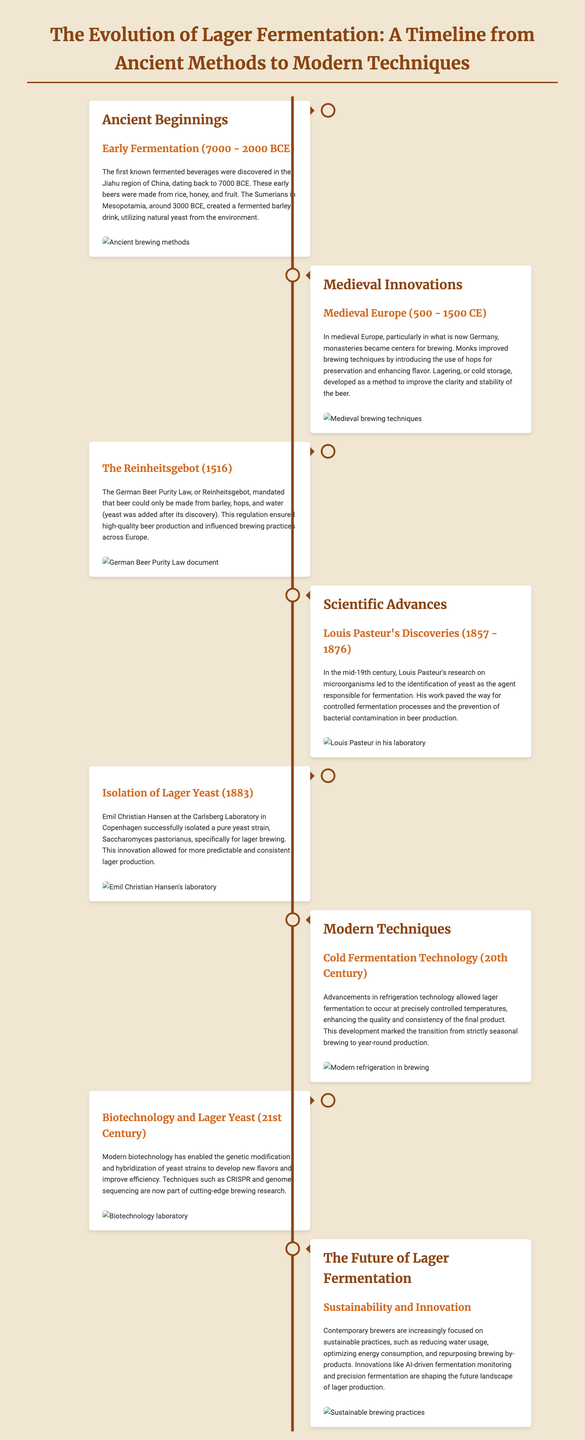What year did early fermentation begin? The document indicates that early fermentation began around 7000 BCE in the Jiahu region of China.
Answer: 7000 BCE What beverage did the Sumerians create around 3000 BCE? The Sumerians created a fermented barley drink around 3000 BCE.
Answer: Fermented barley drink What significant brewing regulation was enacted in 1516? The German Beer Purity Law, or Reinheitsgebot, was enacted in 1516.
Answer: Reinheitsgebot Who identified yeast as the agent responsible for fermentation? Louis Pasteur identified yeast as the agent responsible for fermentation through his research in the mid-19th century.
Answer: Louis Pasteur What yeast strain was isolated by Emil Christian Hansen in 1883? Emil Christian Hansen isolated the Saccharomyces pastorianus yeast strain specifically for lager brewing in 1883.
Answer: Saccharomyces pastorianus What technological advancement allowed for controlled fermentation temperatures in the 20th century? Advancements in refrigeration technology allowed for controlled fermentation temperatures in the 20th century.
Answer: Refrigeration technology Which modern technique is used for developing new flavors in yeast strains? Biotechnology, specifically CRISPR and genome sequencing, allows for developing new flavors in yeast strains.
Answer: Biotechnology What is a key focus of contemporary brewers regarding lager production? Contemporary brewers focus on sustainable practices, including reducing water usage and optimizing energy consumption.
Answer: Sustainability What innovation is mentioned that shapes the future of lager production? AI-driven fermentation monitoring is mentioned as an innovation shaping the future of lager production.
Answer: AI-driven fermentation monitoring 